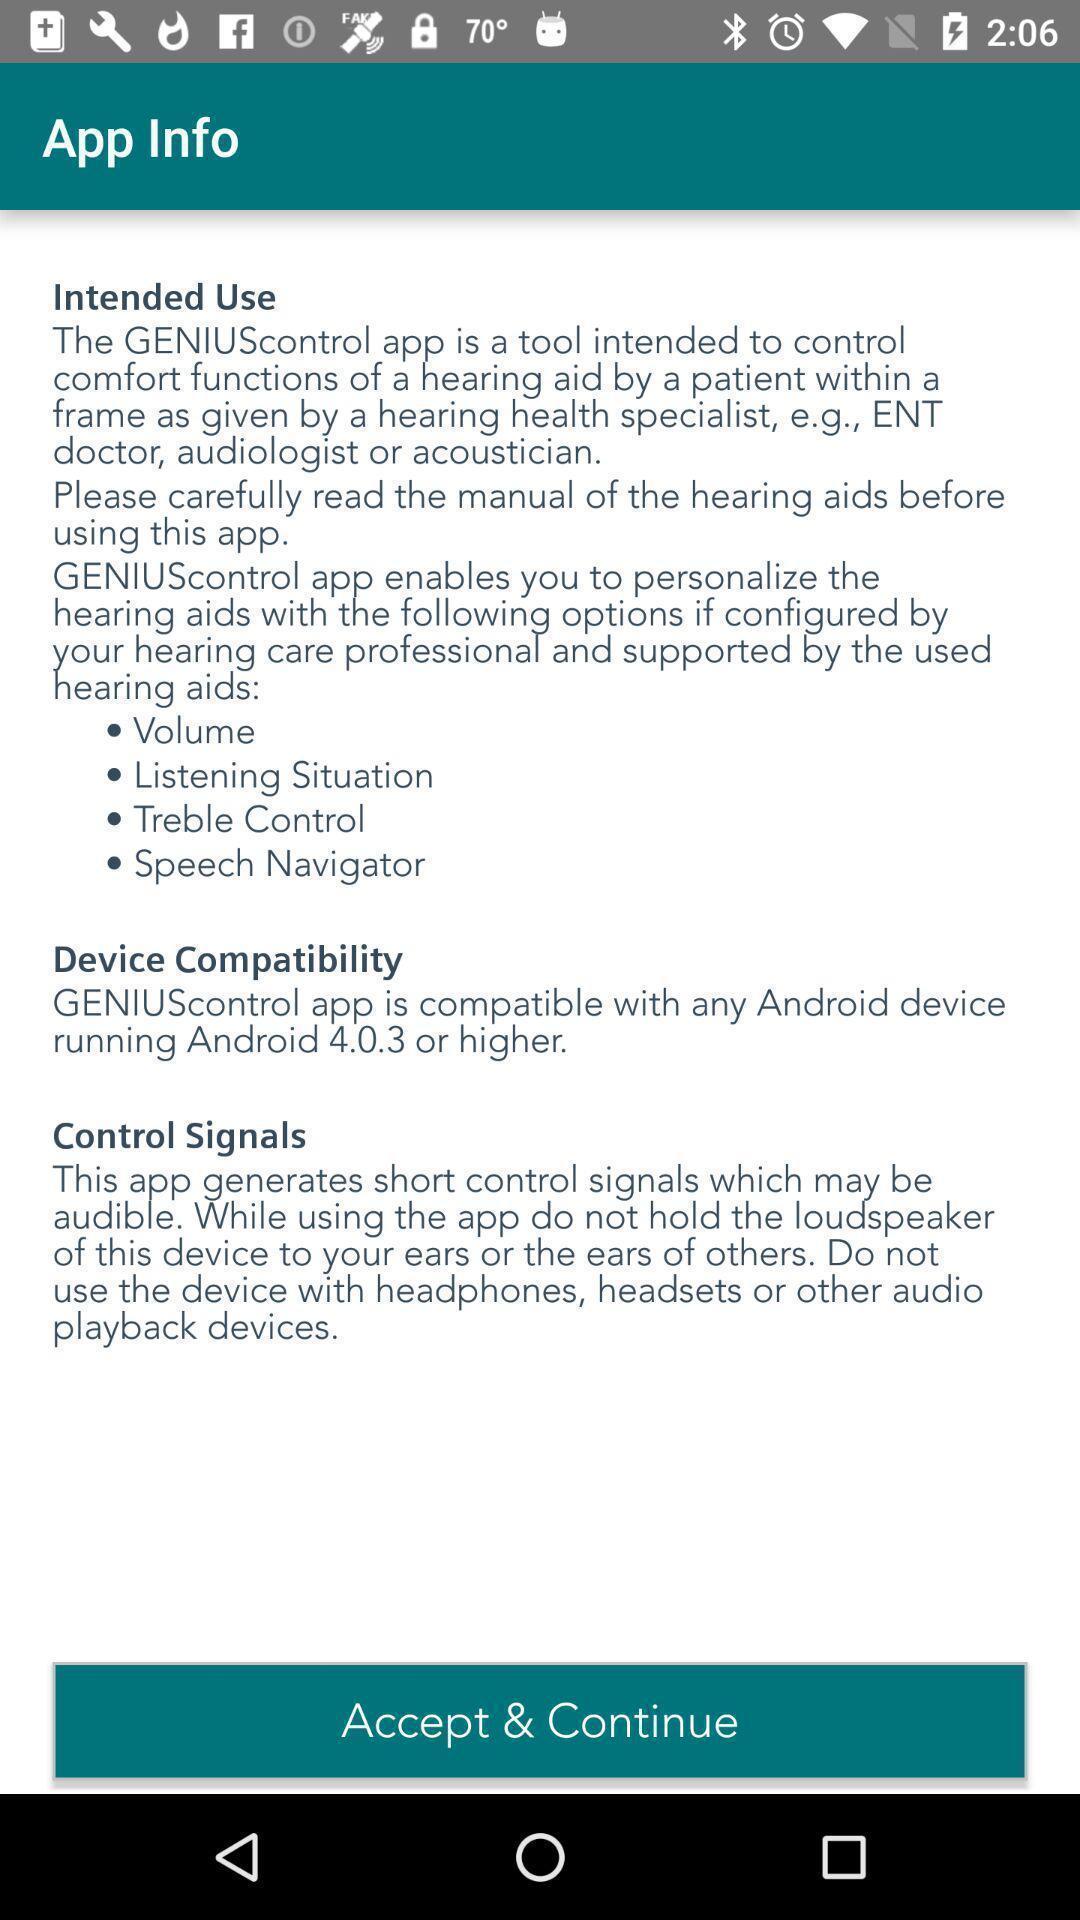What details can you identify in this image? Page showing option like accept continue. 